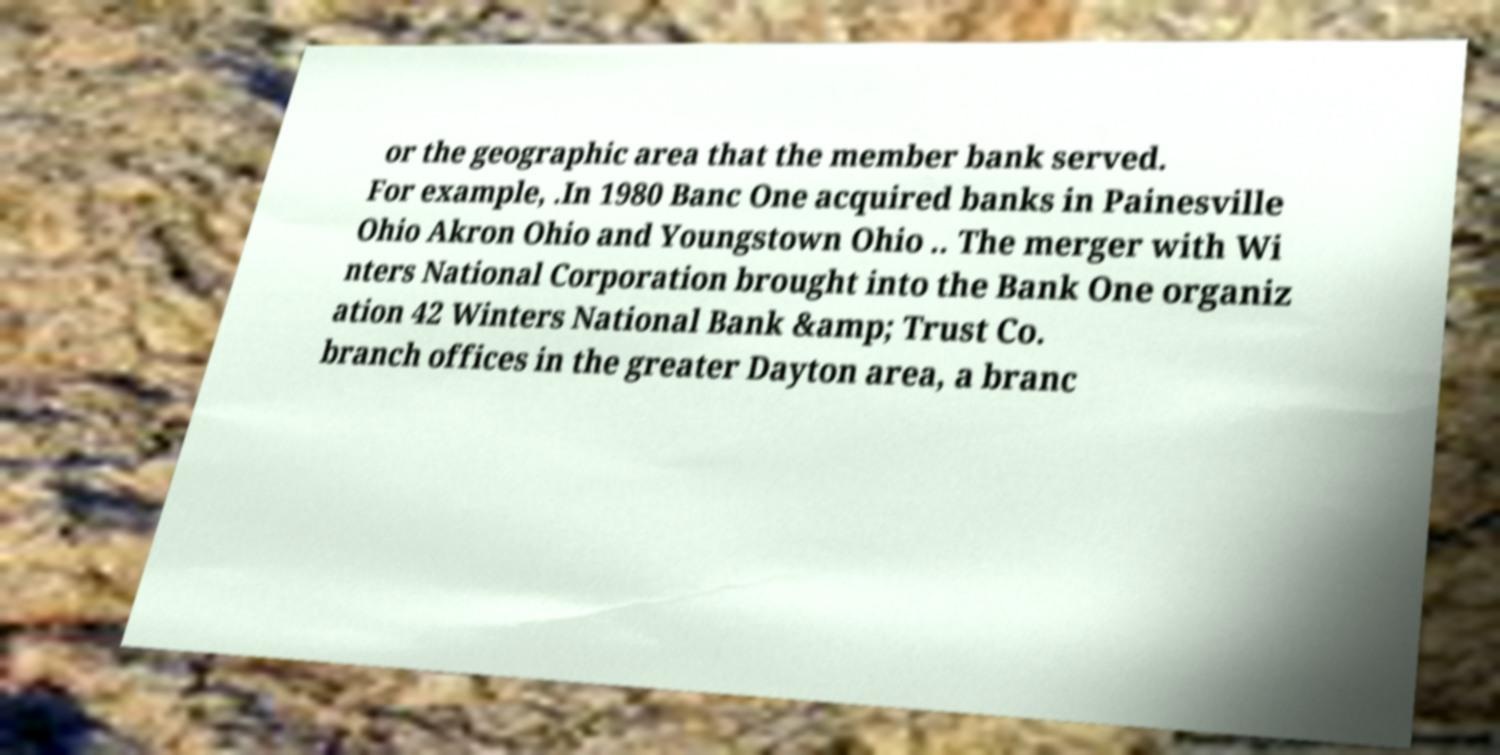There's text embedded in this image that I need extracted. Can you transcribe it verbatim? or the geographic area that the member bank served. For example, .In 1980 Banc One acquired banks in Painesville Ohio Akron Ohio and Youngstown Ohio .. The merger with Wi nters National Corporation brought into the Bank One organiz ation 42 Winters National Bank &amp; Trust Co. branch offices in the greater Dayton area, a branc 